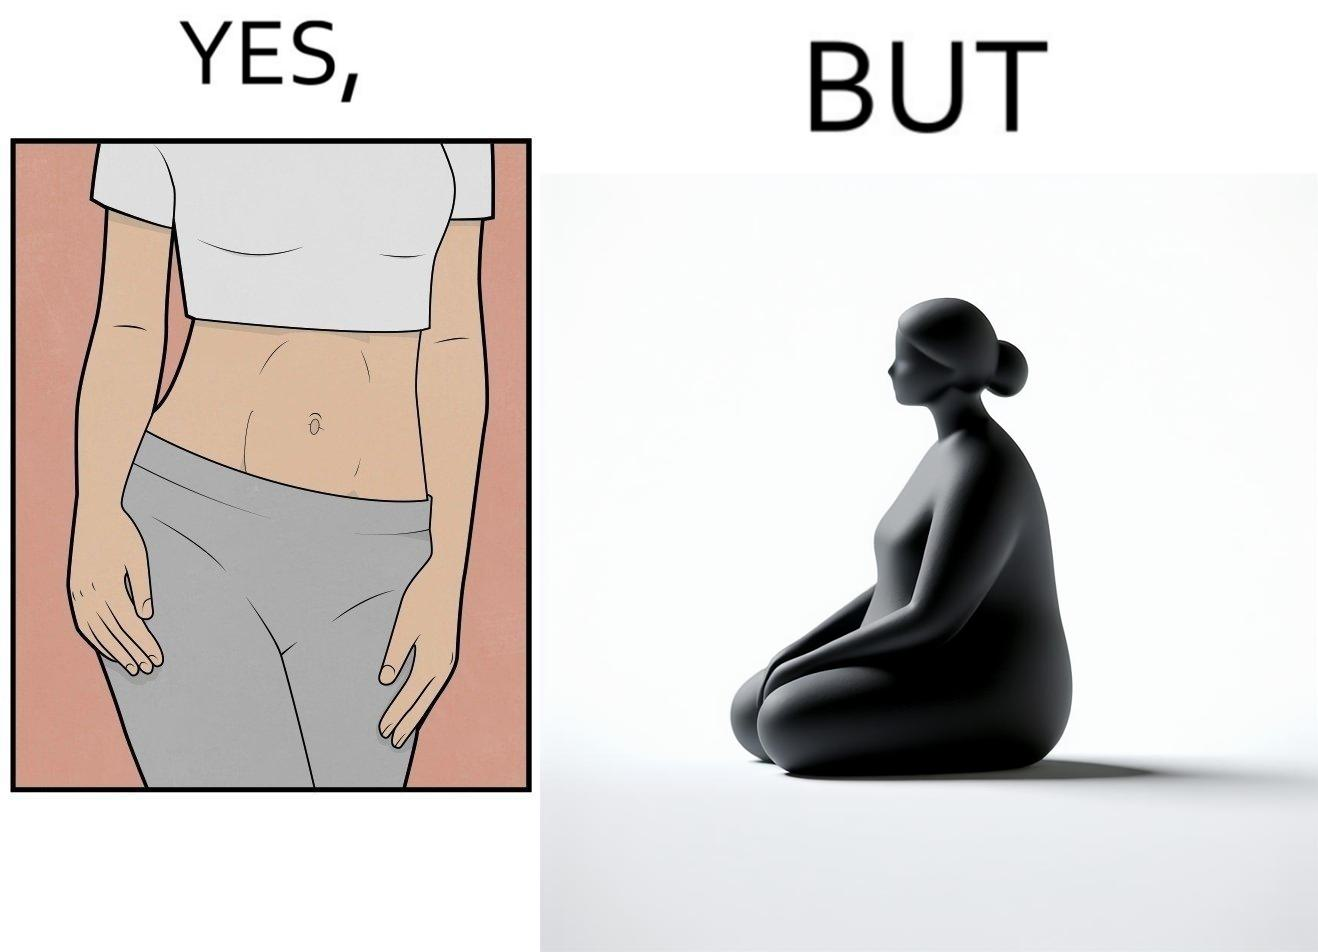Does this image contain satire or humor? Yes, this image is satirical. 